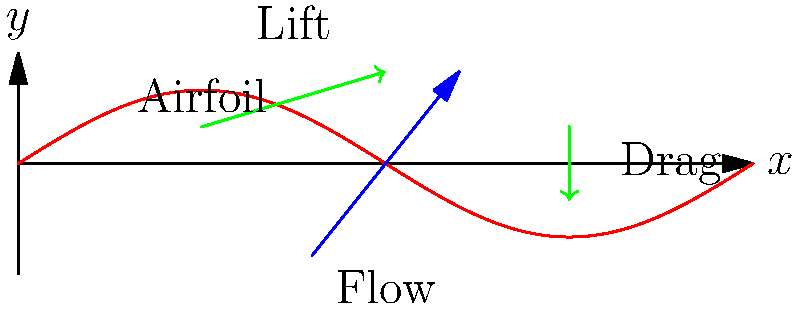Given the airfoil shape shown in the diagram, explain how the pressure distribution around the airfoil contributes to the generation of lift. Additionally, describe the flow pattern differences between the upper and lower surfaces of the airfoil and their impact on the overall aerodynamic performance. To understand the pressure distribution and flow patterns around an airfoil, let's break it down step-by-step:

1. Airfoil shape: The airfoil has a curved upper surface and a flatter lower surface, creating an asymmetrical shape.

2. Bernoulli's principle: As air flows over the airfoil, it follows the principle that faster-moving air has lower pressure.

3. Flow velocity:
   a. Upper surface: Air travels a longer distance over the curved upper surface, resulting in higher velocity.
   b. Lower surface: Air travels a shorter distance, resulting in lower velocity.

4. Pressure distribution:
   a. Upper surface: Higher velocity leads to lower pressure.
   b. Lower surface: Lower velocity leads to higher pressure.

5. Lift generation: The pressure difference between the upper (low pressure) and lower (high pressure) surfaces creates an upward force called lift.

6. Flow separation: At high angles of attack, flow may separate from the upper surface, reducing lift and increasing drag.

7. Boundary layer: A thin layer of air close to the airfoil surface experiences friction, affecting the overall flow pattern.

8. Circulation: The flow pattern creates a circulation around the airfoil, contributing to lift generation according to the Kutta-Joukowski theorem.

9. Angle of attack: Increasing the angle of attack generally increases lift up to a critical angle, after which stall occurs.

10. Drag: The flow pattern also contributes to drag, which is the force opposing the airfoil's motion through the air.

The combination of these factors results in the complex flow patterns and pressure distribution that determine the airfoil's aerodynamic performance.
Answer: Pressure difference between upper (low) and lower (high) surfaces creates lift; flow velocity is higher on upper surface due to curvature, leading to lower pressure (Bernoulli's principle). 